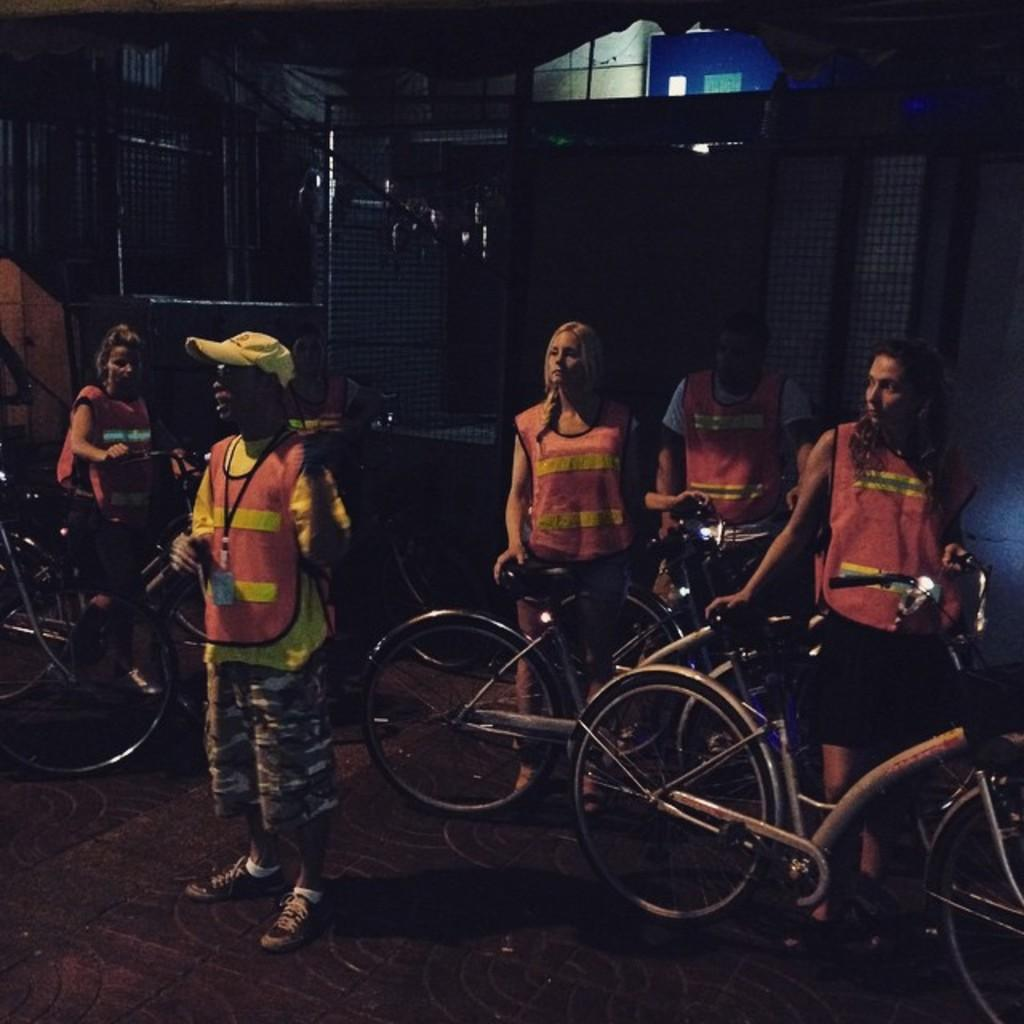Who is present in the image? There are people in the image. Where are the people located? The people are standing on the road. What are the people holding or riding? The people have bicycles. Can you describe the clothing of one of the people? There is a person wearing a cap. What year is the band performing in the image? There is no band present in the image, so it is not possible to determine the year of a performance. 